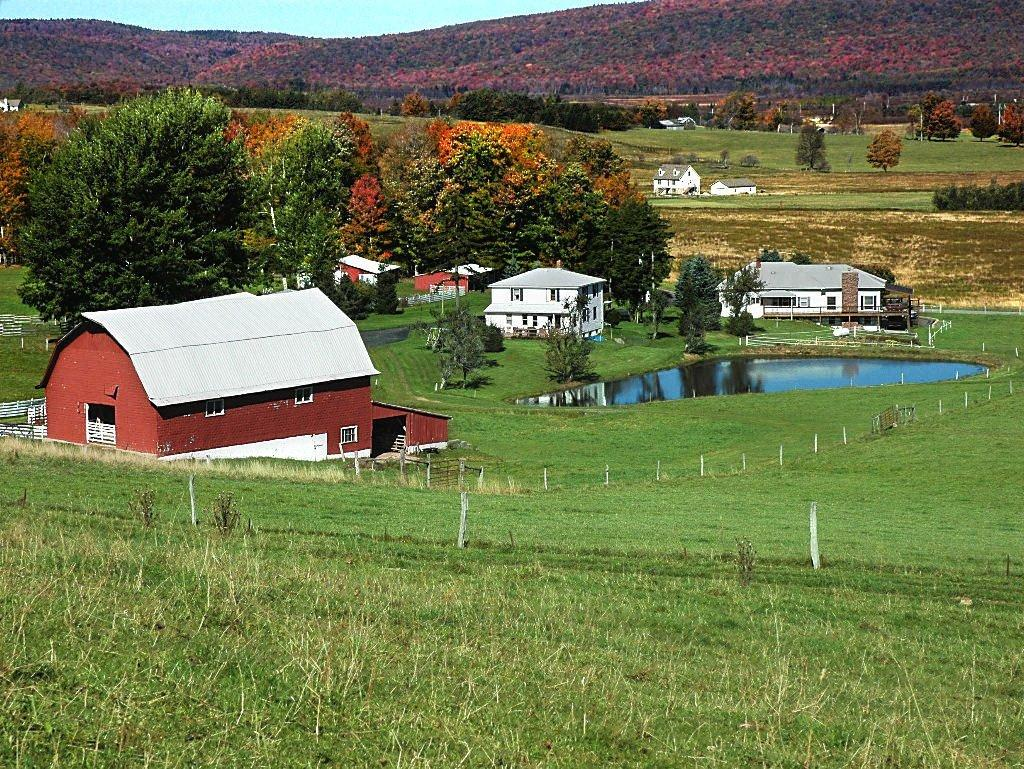What type of structures can be seen in the image? There are houses in the image. What is the tall, vertical object in the image? There is a pole in the image. What type of natural vegetation is present in the image? There are trees in the image. What is visible in the background of the image? The sky is visible in the image. What is the elevated landform in the image? There is a hill in the image. What type of ground cover is present at the bottom of the image? Grass is present at the bottom of the image. What type of smell can be detected coming from the hill in the image? There is no indication of any smell in the image, and therefore it cannot be determined from the image. Is there a trail visible in the image? There is no trail present in the image. 